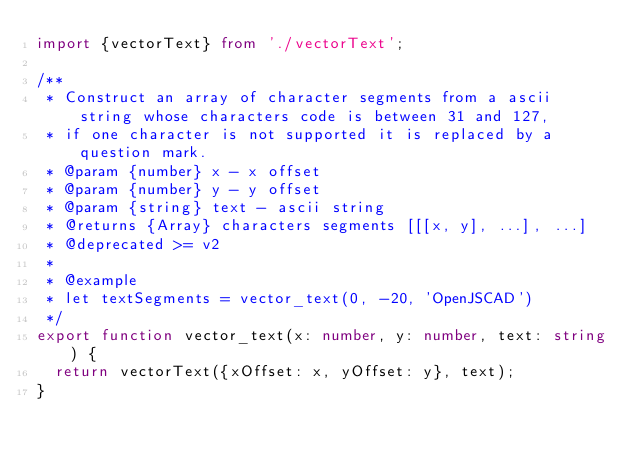Convert code to text. <code><loc_0><loc_0><loc_500><loc_500><_TypeScript_>import {vectorText} from './vectorText';

/**
 * Construct an array of character segments from a ascii string whose characters code is between 31 and 127,
 * if one character is not supported it is replaced by a question mark.
 * @param {number} x - x offset
 * @param {number} y - y offset
 * @param {string} text - ascii string
 * @returns {Array} characters segments [[[x, y], ...], ...]
 * @deprecated >= v2
 *
 * @example
 * let textSegments = vector_text(0, -20, 'OpenJSCAD')
 */
export function vector_text(x: number, y: number, text: string) {
  return vectorText({xOffset: x, yOffset: y}, text);
}
</code> 